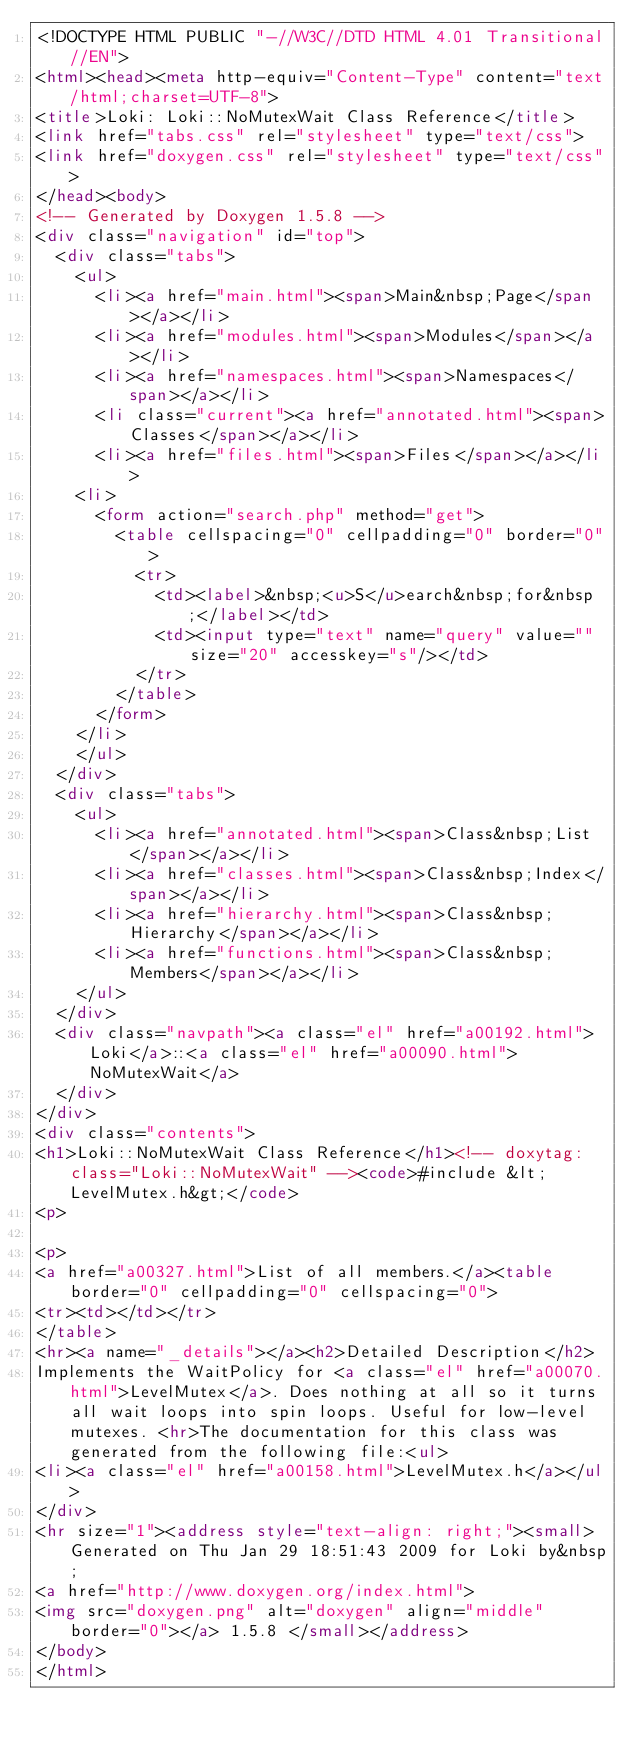<code> <loc_0><loc_0><loc_500><loc_500><_HTML_><!DOCTYPE HTML PUBLIC "-//W3C//DTD HTML 4.01 Transitional//EN">
<html><head><meta http-equiv="Content-Type" content="text/html;charset=UTF-8">
<title>Loki: Loki::NoMutexWait Class Reference</title>
<link href="tabs.css" rel="stylesheet" type="text/css">
<link href="doxygen.css" rel="stylesheet" type="text/css">
</head><body>
<!-- Generated by Doxygen 1.5.8 -->
<div class="navigation" id="top">
  <div class="tabs">
    <ul>
      <li><a href="main.html"><span>Main&nbsp;Page</span></a></li>
      <li><a href="modules.html"><span>Modules</span></a></li>
      <li><a href="namespaces.html"><span>Namespaces</span></a></li>
      <li class="current"><a href="annotated.html"><span>Classes</span></a></li>
      <li><a href="files.html"><span>Files</span></a></li>
    <li>
      <form action="search.php" method="get">
        <table cellspacing="0" cellpadding="0" border="0">
          <tr>
            <td><label>&nbsp;<u>S</u>earch&nbsp;for&nbsp;</label></td>
            <td><input type="text" name="query" value="" size="20" accesskey="s"/></td>
          </tr>
        </table>
      </form>
    </li>
    </ul>
  </div>
  <div class="tabs">
    <ul>
      <li><a href="annotated.html"><span>Class&nbsp;List</span></a></li>
      <li><a href="classes.html"><span>Class&nbsp;Index</span></a></li>
      <li><a href="hierarchy.html"><span>Class&nbsp;Hierarchy</span></a></li>
      <li><a href="functions.html"><span>Class&nbsp;Members</span></a></li>
    </ul>
  </div>
  <div class="navpath"><a class="el" href="a00192.html">Loki</a>::<a class="el" href="a00090.html">NoMutexWait</a>
  </div>
</div>
<div class="contents">
<h1>Loki::NoMutexWait Class Reference</h1><!-- doxytag: class="Loki::NoMutexWait" --><code>#include &lt;LevelMutex.h&gt;</code>
<p>

<p>
<a href="a00327.html">List of all members.</a><table border="0" cellpadding="0" cellspacing="0">
<tr><td></td></tr>
</table>
<hr><a name="_details"></a><h2>Detailed Description</h2>
Implements the WaitPolicy for <a class="el" href="a00070.html">LevelMutex</a>. Does nothing at all so it turns all wait loops into spin loops. Useful for low-level mutexes. <hr>The documentation for this class was generated from the following file:<ul>
<li><a class="el" href="a00158.html">LevelMutex.h</a></ul>
</div>
<hr size="1"><address style="text-align: right;"><small>Generated on Thu Jan 29 18:51:43 2009 for Loki by&nbsp;
<a href="http://www.doxygen.org/index.html">
<img src="doxygen.png" alt="doxygen" align="middle" border="0"></a> 1.5.8 </small></address>
</body>
</html>
</code> 